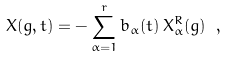Convert formula to latex. <formula><loc_0><loc_0><loc_500><loc_500>X ( g , t ) = - \sum _ { \alpha = 1 } ^ { r } b _ { \alpha } ( t ) \, X ^ { R } _ { \alpha } ( g ) \ ,</formula> 